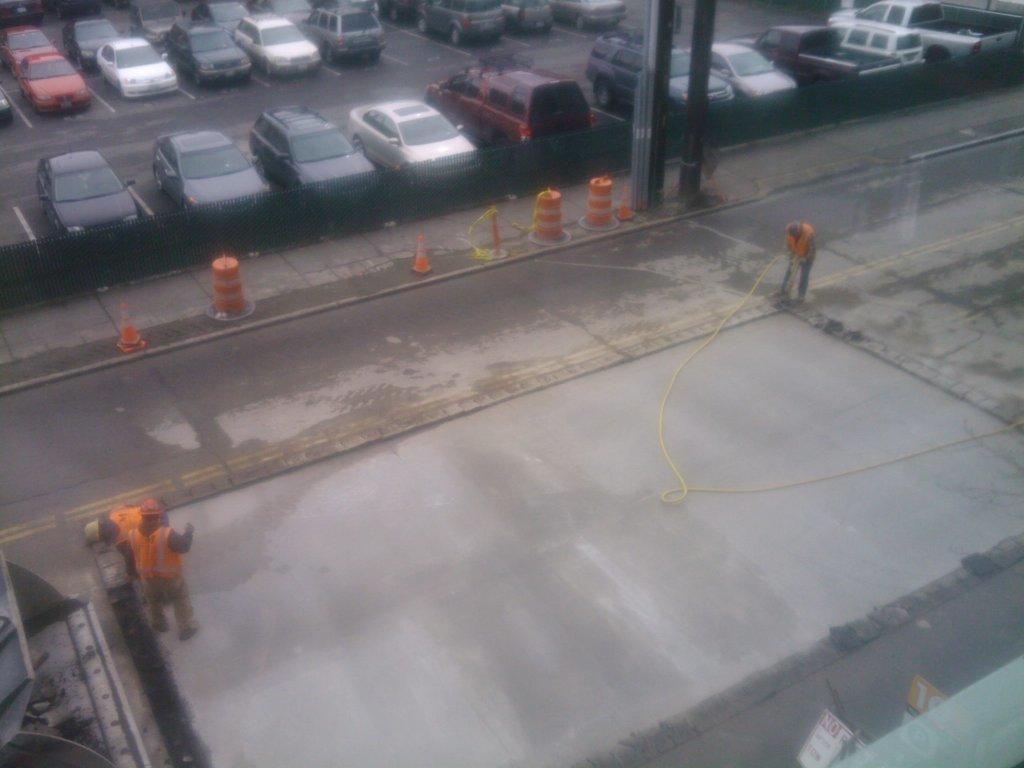Describe this image in one or two sentences. At the bottom we can see metal object, hoardings, pipe and few persons are standing on the road. There are plants, poles and vehicles on the road. 